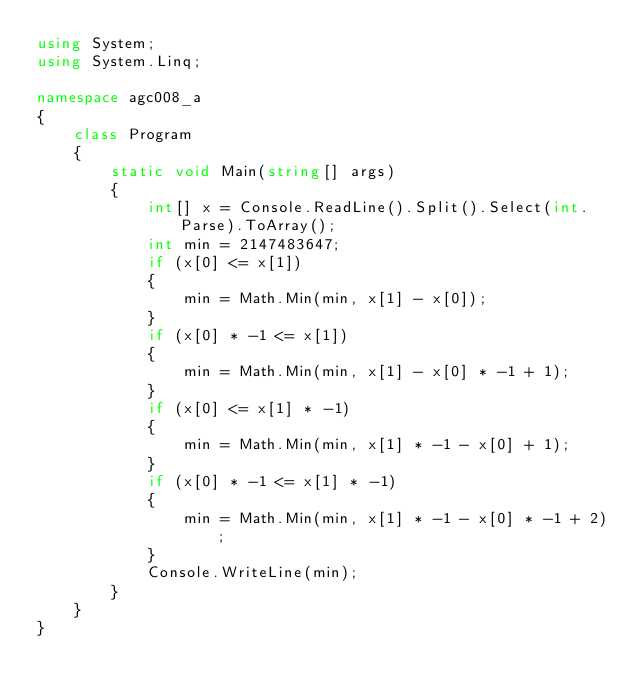Convert code to text. <code><loc_0><loc_0><loc_500><loc_500><_C#_>using System;
using System.Linq;

namespace agc008_a
{
    class Program
    {
        static void Main(string[] args)
        {
            int[] x = Console.ReadLine().Split().Select(int.Parse).ToArray();
            int min = 2147483647;
            if (x[0] <= x[1])
            {
                min = Math.Min(min, x[1] - x[0]);
            }
            if (x[0] * -1 <= x[1])
            {
                min = Math.Min(min, x[1] - x[0] * -1 + 1);
            }
            if (x[0] <= x[1] * -1)
            {
                min = Math.Min(min, x[1] * -1 - x[0] + 1);
            }
            if (x[0] * -1 <= x[1] * -1)
            {
                min = Math.Min(min, x[1] * -1 - x[0] * -1 + 2);
            }
            Console.WriteLine(min);
        }
    }
}</code> 